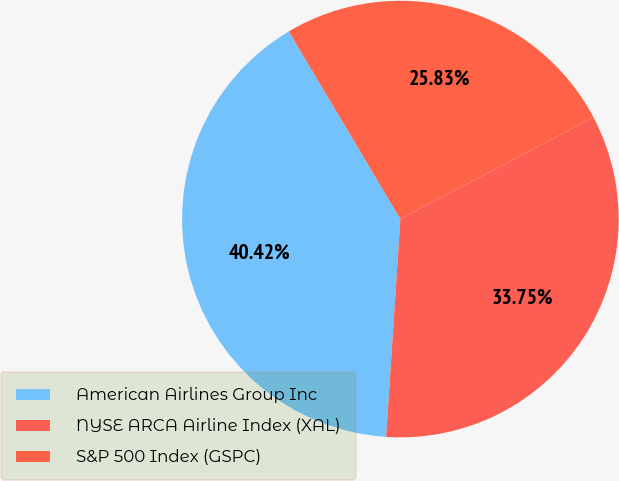Convert chart to OTSL. <chart><loc_0><loc_0><loc_500><loc_500><pie_chart><fcel>American Airlines Group Inc<fcel>NYSE ARCA Airline Index (XAL)<fcel>S&P 500 Index (GSPC)<nl><fcel>40.42%<fcel>33.75%<fcel>25.83%<nl></chart> 